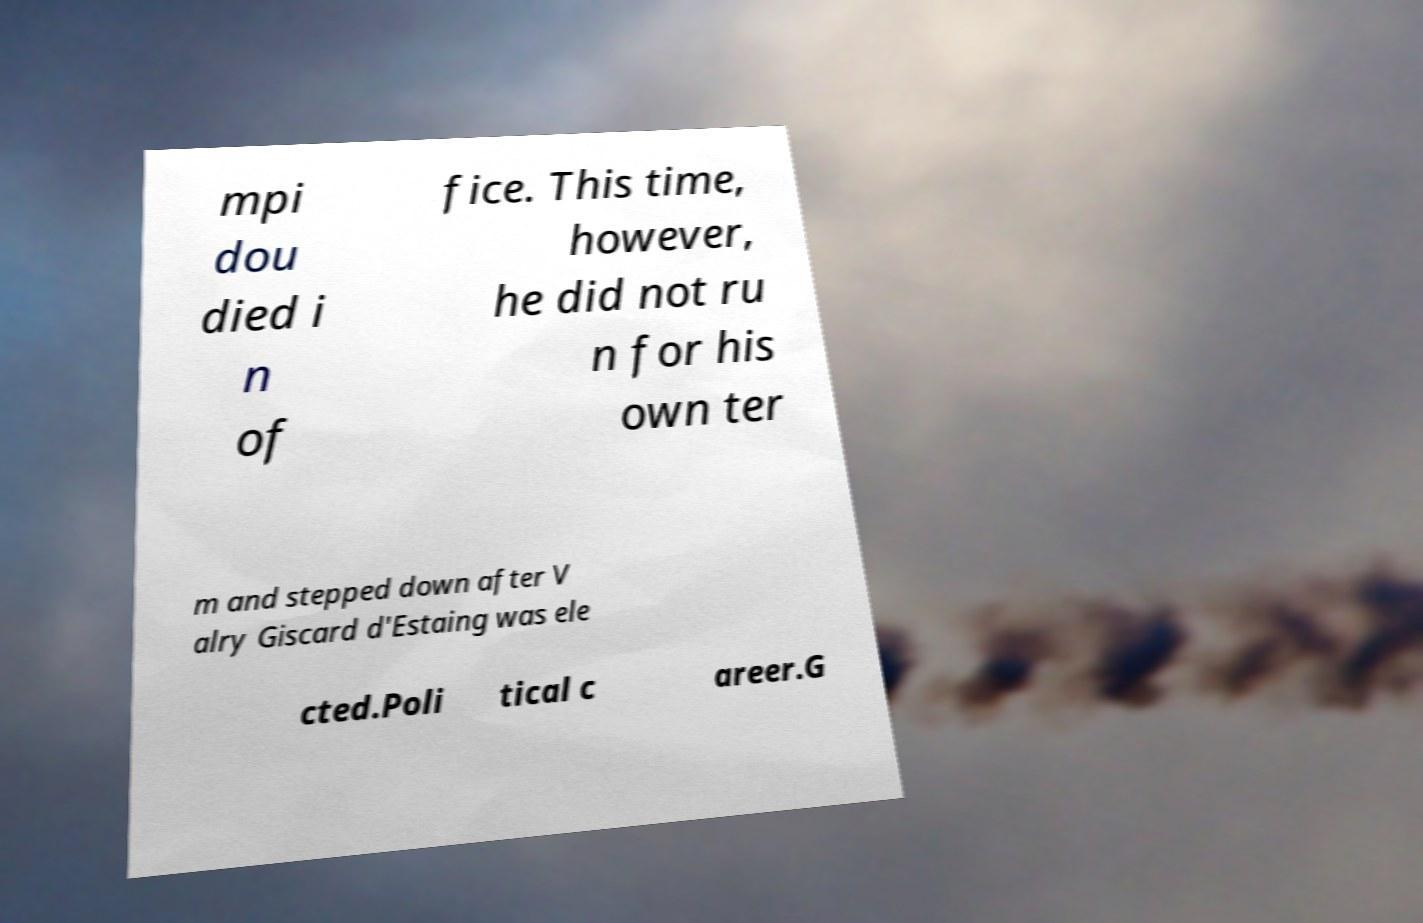Can you read and provide the text displayed in the image?This photo seems to have some interesting text. Can you extract and type it out for me? mpi dou died i n of fice. This time, however, he did not ru n for his own ter m and stepped down after V alry Giscard d'Estaing was ele cted.Poli tical c areer.G 